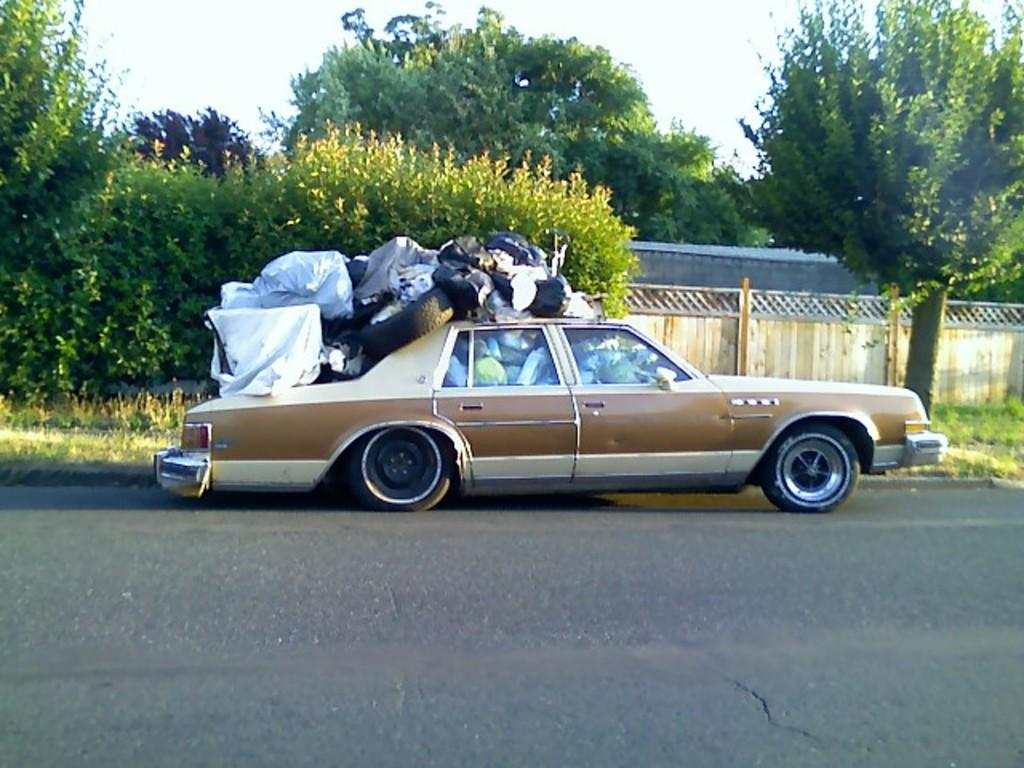What is the main subject of the image? There is a car on the road in the image. What can be seen inside the car? There are objects and tires inside the car. What is located above the car? There are objects and tires above the car. What can be seen in the background of the image? There is a fence wall and trees in the background of the image. How many legs can be seen on the car in the image? Cars do not have legs, so there are no legs visible on the car in the image. What type of faucet is present in the image? There is no faucet present in the image. 